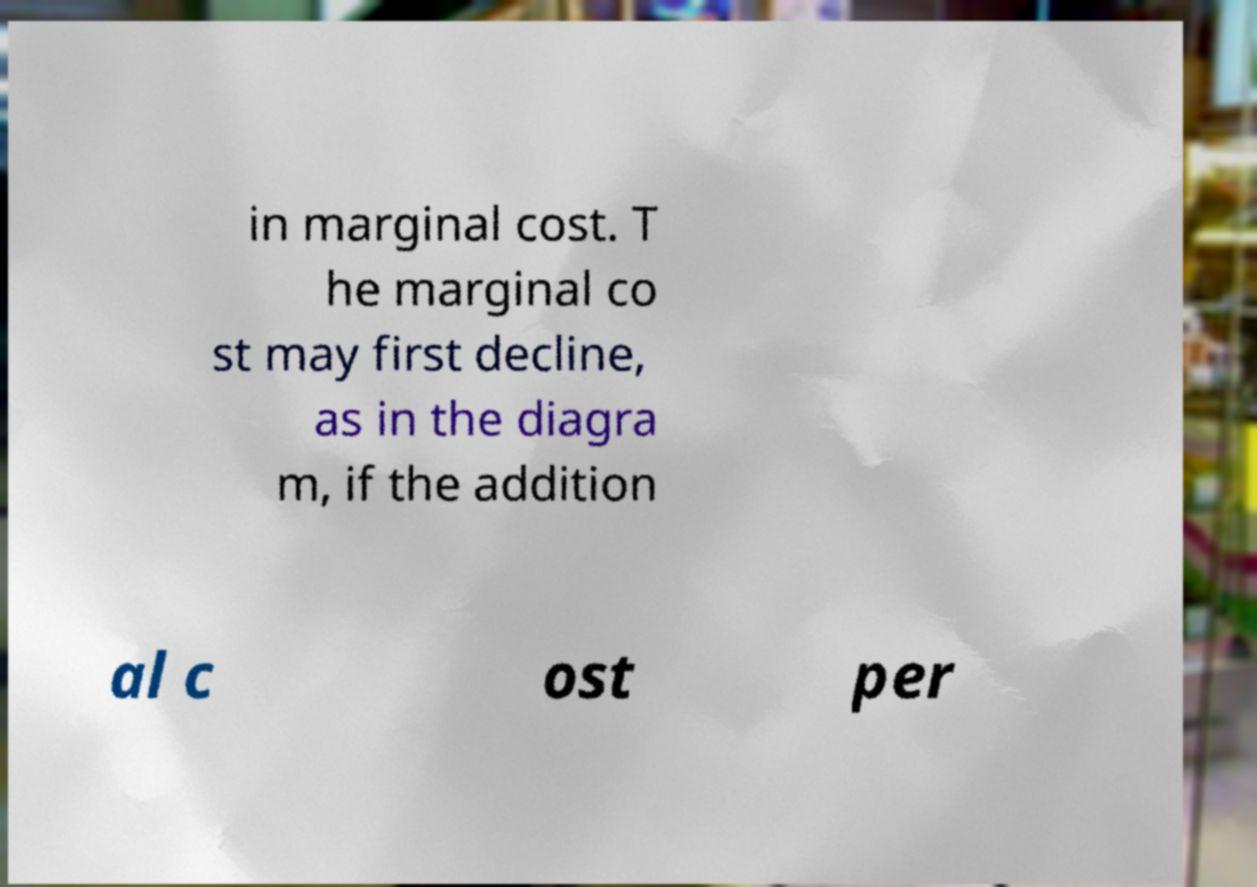Could you extract and type out the text from this image? in marginal cost. T he marginal co st may first decline, as in the diagra m, if the addition al c ost per 